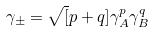<formula> <loc_0><loc_0><loc_500><loc_500>\gamma _ { \pm } = \sqrt { [ } p + q ] { \gamma _ { A } ^ { p } \gamma _ { B } ^ { q } }</formula> 